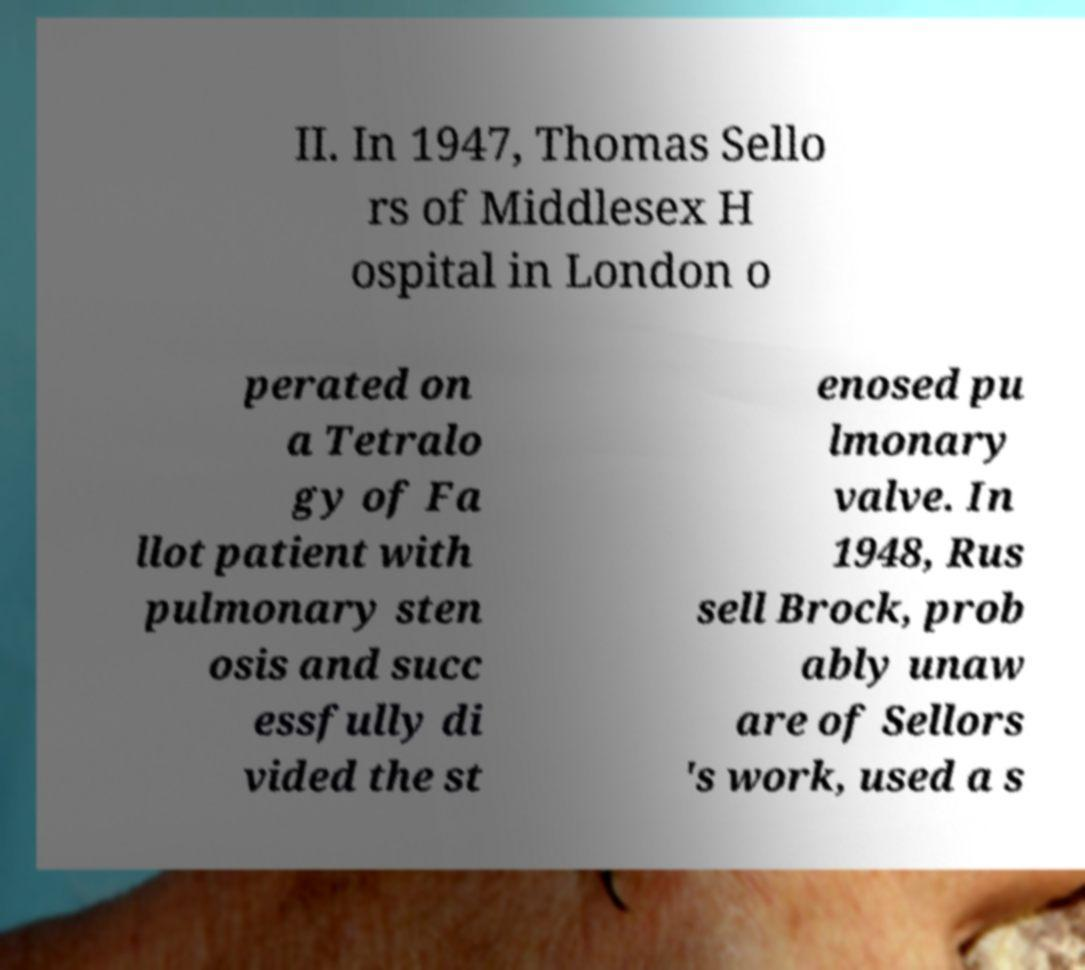I need the written content from this picture converted into text. Can you do that? II. In 1947, Thomas Sello rs of Middlesex H ospital in London o perated on a Tetralo gy of Fa llot patient with pulmonary sten osis and succ essfully di vided the st enosed pu lmonary valve. In 1948, Rus sell Brock, prob ably unaw are of Sellors 's work, used a s 